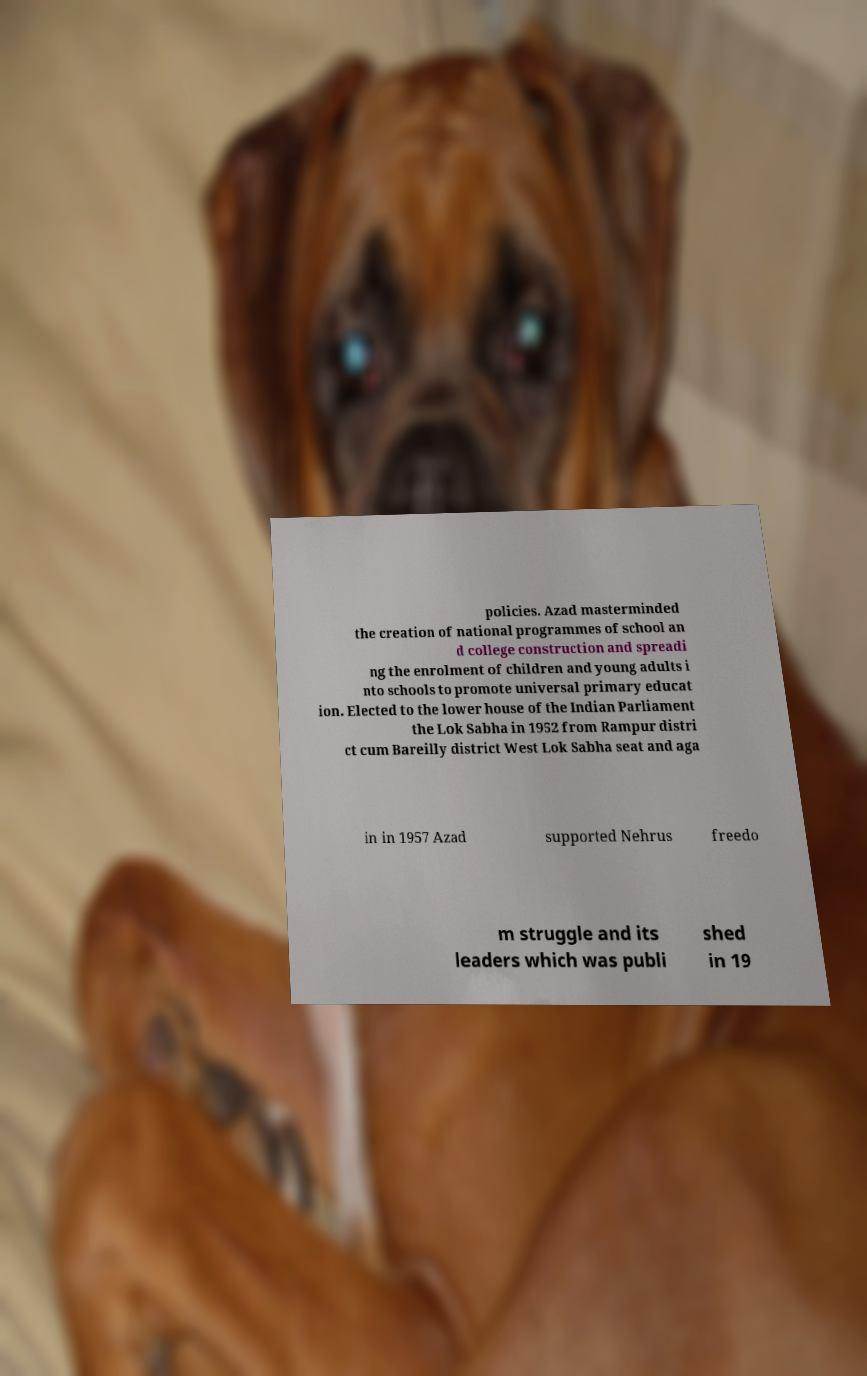Could you assist in decoding the text presented in this image and type it out clearly? policies. Azad masterminded the creation of national programmes of school an d college construction and spreadi ng the enrolment of children and young adults i nto schools to promote universal primary educat ion. Elected to the lower house of the Indian Parliament the Lok Sabha in 1952 from Rampur distri ct cum Bareilly district West Lok Sabha seat and aga in in 1957 Azad supported Nehrus freedo m struggle and its leaders which was publi shed in 19 